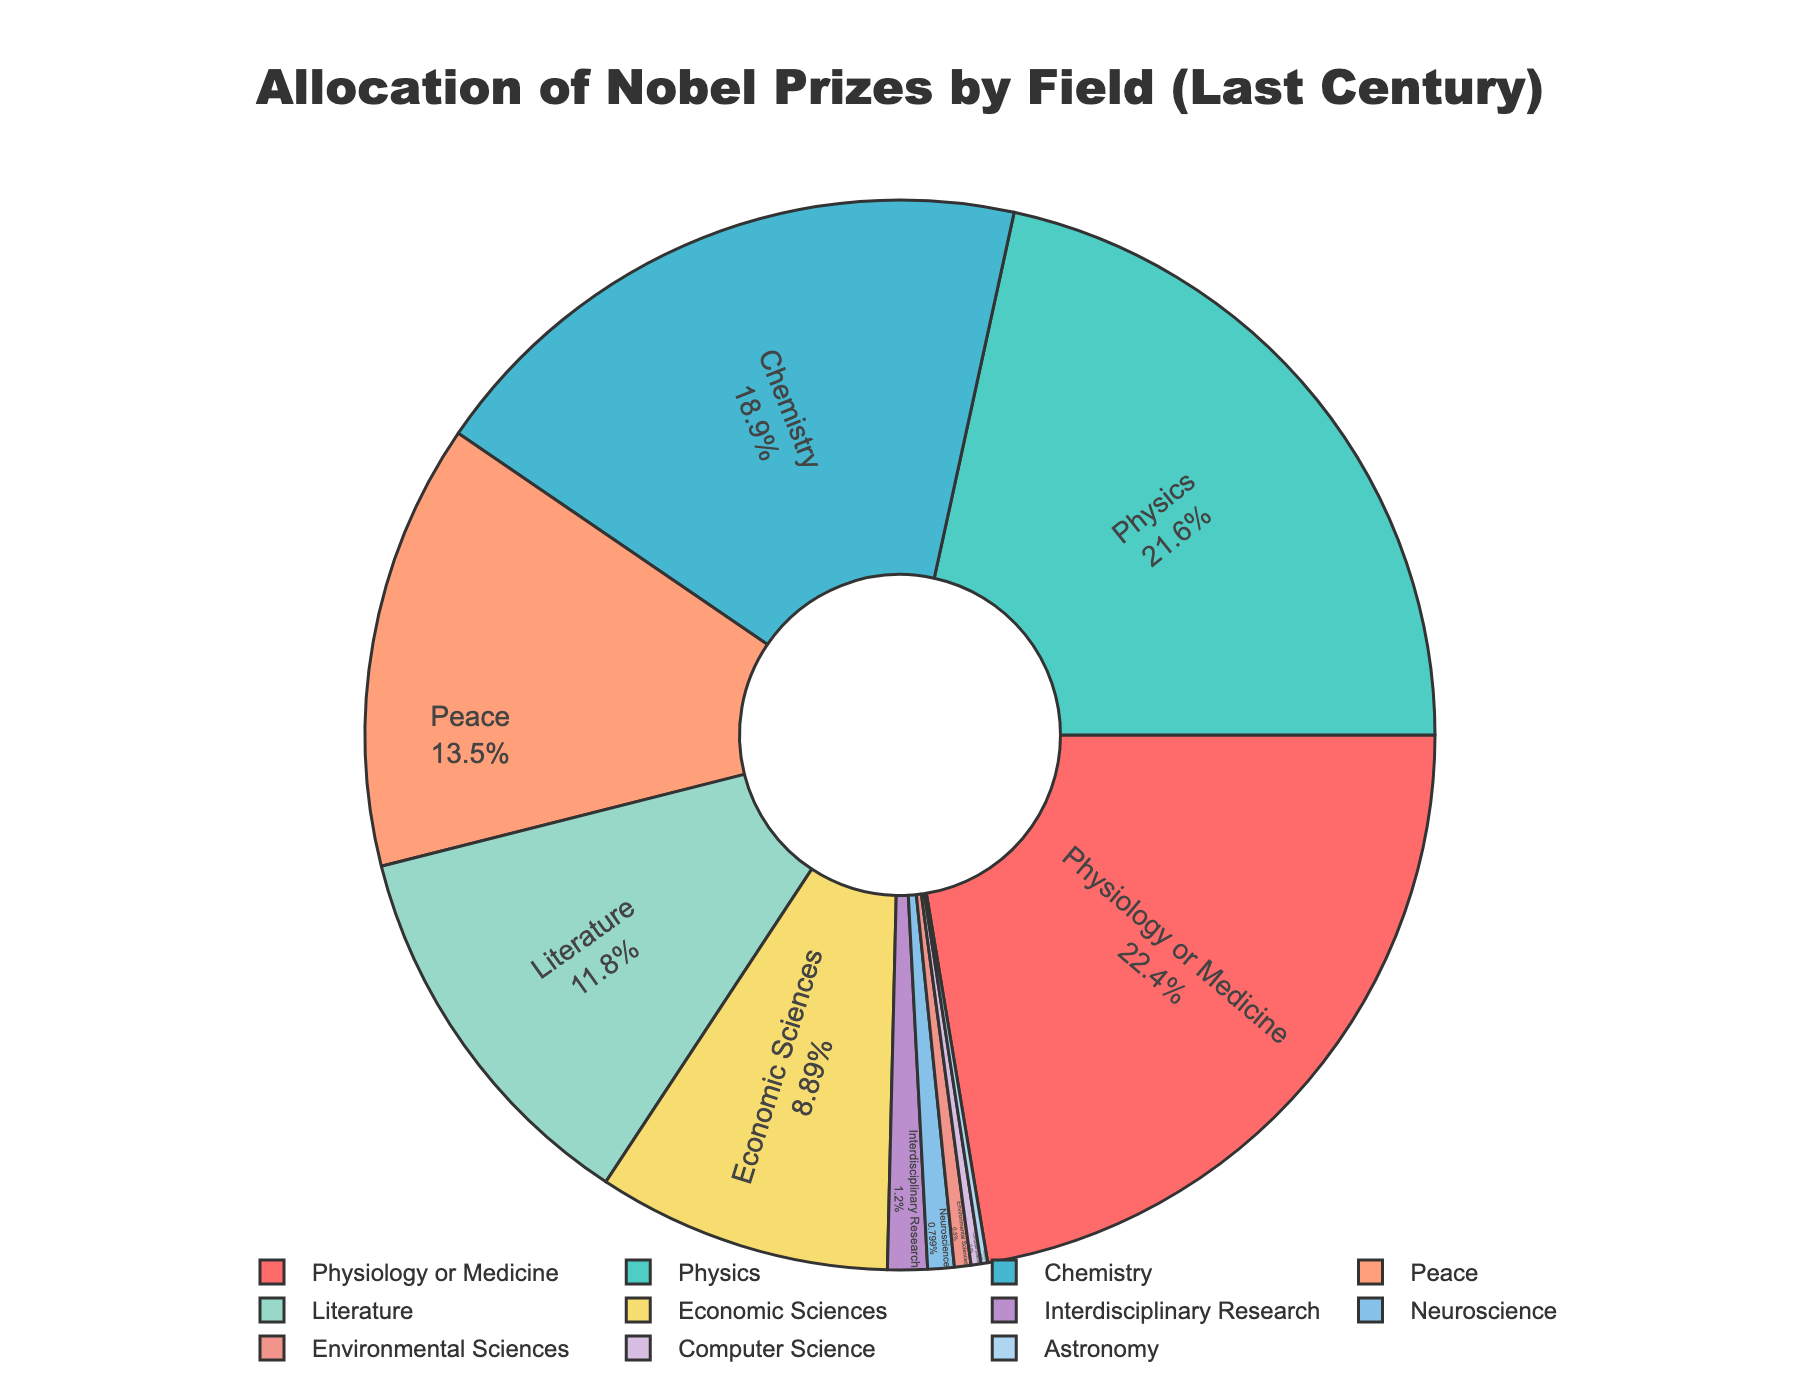what is the field with the highest number of Nobel Prizes? The slice with the highest percentage indicates the field with the highest number of Nobel Prizes, which is "Physiology or Medicine".
Answer: Physiology or Medicine How many more Nobel Prizes have been awarded in Physics compared to Literature? The number for Physics is 216, and for Literature, it is 118. Subtraction operation: 216 - 118 = 98.
Answer: 98 Which field has received fewer Nobel Prizes: Computer Science or Environmental Sciences? Compare the two slices representing Computer Science and Environmental Sciences. Computer Science has 3, while Environmental Sciences has 5.
Answer: Computer Science What percentage of the total Nobel Prizes were awarded in Economic Sciences? Find the slice labeled "Economic Sciences" and note its percentage. The share for Economic Sciences is approximately 5.5%.
Answer: Approximately 5.5% What is the combined total of Nobel Prizes awarded in fields related to Earth and space sciences (Environmental Sciences + Astronomy)? Add the number of prizes for Environmental Sciences (5) and Astronomy (2): 5 + 2 = 7.
Answer: 7 Which fields constitute the smallest three slices in terms of percentage, and how many total Nobel Prizes were awarded in these fields combined? Identify the three smallest slices: Astronomy (2), Computer Science (3), and Neuroscience (8). Calculate their sum: 2 + 3 + 8 = 13.
Answer: Astronomy, Computer Science, Neuroscience; 13 By what percentage does the number of Nobel Prizes in Chemistry exceed those in Peace? Chemistry has 189 and Peace has 135. First, find the difference: 189 - 135 = 54. To find the percentage: (54 / 135) * 100 ≈ 40%.
Answer: Approximately 40% What field has received the second-highest number of Nobel Prizes, and how does it compare to the number in Chemistry? The second-highest field is Physics with 216 Nobel Prizes; Chemistry has 189. Subtract Chemistry's count from Physics: 216 - 189 = 27.
Answer: Physics; 27 more Is the number of Nobel Prizes awarded for Literature closer to that of Peace or Economic Sciences? Compare the differences: Literature (118) and Peace (135) = 17; Literature and Economic Sciences (89) = 29. 17 < 29, so it is closer to Peace.
Answer: Peace Are there more Nobel Prizes awarded in Interdisciplinary Research or Environmental Sciences and how many more? Interdisciplinary Research has 12, and Environmental Sciences has 5. Subtract: 12 - 5 = 7.
Answer: Interdisciplinary Research; 7 more 